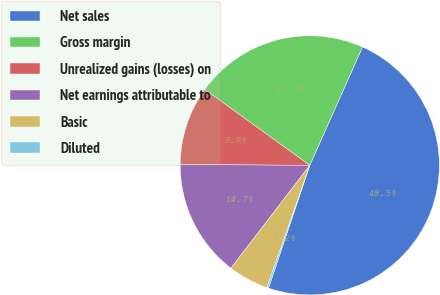Convert chart to OTSL. <chart><loc_0><loc_0><loc_500><loc_500><pie_chart><fcel>Net sales<fcel>Gross margin<fcel>Unrealized gains (losses) on<fcel>Net earnings attributable to<fcel>Basic<fcel>Diluted<nl><fcel>48.49%<fcel>21.71%<fcel>9.86%<fcel>14.69%<fcel>5.04%<fcel>0.21%<nl></chart> 